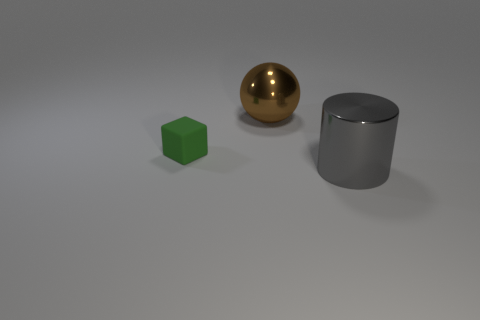Are there any other things that have the same shape as the small object?
Provide a succinct answer. No. The big thing that is made of the same material as the big sphere is what shape?
Your answer should be compact. Cylinder. Are there the same number of large gray objects that are in front of the big cylinder and cyan matte objects?
Your answer should be compact. Yes. Does the large thing in front of the matte object have the same material as the large object behind the small green rubber object?
Provide a succinct answer. Yes. There is a large metal object to the right of the big object behind the tiny green thing; what is its shape?
Provide a short and direct response. Cylinder. There is a big cylinder that is made of the same material as the ball; what is its color?
Your answer should be very brief. Gray. There is a thing that is the same size as the metal ball; what shape is it?
Provide a short and direct response. Cylinder. What size is the block?
Your answer should be very brief. Small. Is the size of the metal thing in front of the ball the same as the thing on the left side of the brown object?
Your answer should be compact. No. There is a shiny thing that is behind the big thing in front of the big brown metal thing; what is its color?
Your answer should be compact. Brown. 